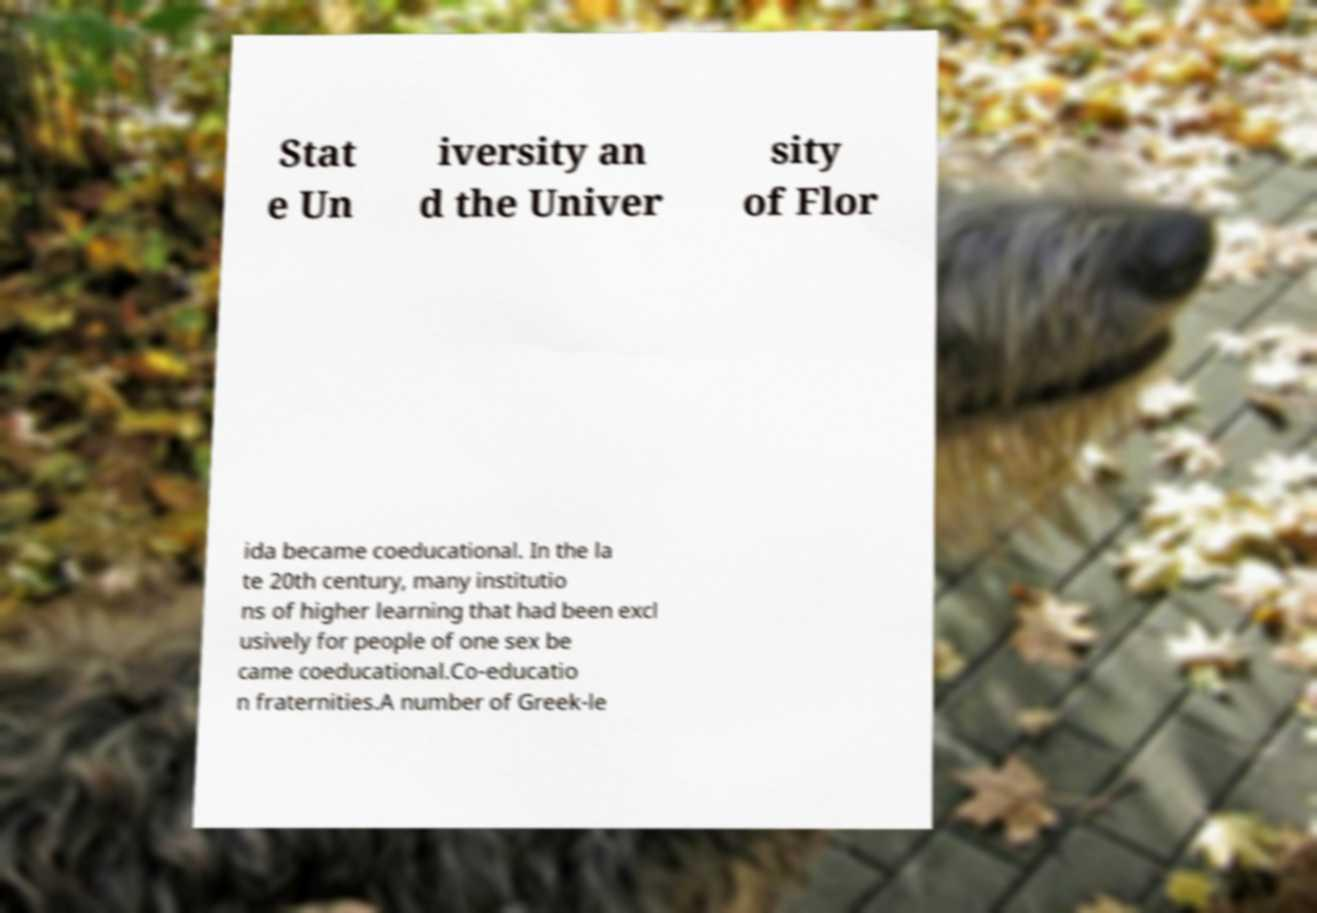What messages or text are displayed in this image? I need them in a readable, typed format. Stat e Un iversity an d the Univer sity of Flor ida became coeducational. In the la te 20th century, many institutio ns of higher learning that had been excl usively for people of one sex be came coeducational.Co-educatio n fraternities.A number of Greek-le 